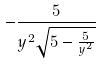Convert formula to latex. <formula><loc_0><loc_0><loc_500><loc_500>- \frac { 5 } { y ^ { 2 } \sqrt { 5 - \frac { 5 } { y ^ { 2 } } } }</formula> 